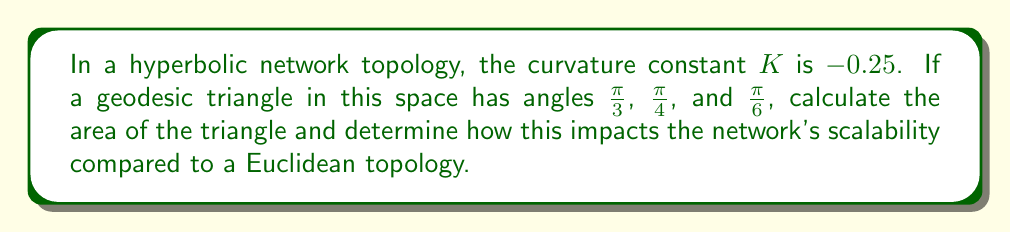Can you solve this math problem? 1) In hyperbolic geometry, the area $A$ of a triangle is given by the formula:

   $$A = \frac{(\alpha + \beta + \gamma - \pi)}{|K|}$$

   where $\alpha$, $\beta$, and $\gamma$ are the angles of the triangle, and $K$ is the curvature constant.

2) Given angles: $\alpha = \frac{\pi}{3}$, $\beta = \frac{\pi}{4}$, and $\gamma = \frac{\pi}{6}$

3) Sum of angles:
   $$\frac{\pi}{3} + \frac{\pi}{4} + \frac{\pi}{6} = \frac{4\pi}{12} + \frac{3\pi}{12} + \frac{2\pi}{12} = \frac{9\pi}{12} = \frac{3\pi}{4}$$

4) Substitute into the area formula:
   $$A = \frac{(\frac{3\pi}{4} - \pi)}{|-0.25|} = \frac{-\frac{\pi}{4}}{0.25} = -\pi$$

5) The negative area is a characteristic of hyperbolic geometry. The absolute value, $\pi$, represents the actual area.

6) In a hyperbolic network topology, this larger-than-expected triangle area implies that more nodes can be placed within a given region compared to a Euclidean topology. This leads to improved scalability, as the network can accommodate more devices or connections within the same logical space.

7) The exponential growth of available space in hyperbolic geometry allows for more efficient routing and addressing schemes, potentially reducing network congestion and improving overall performance as the network scales.
Answer: Area = $\pi$; Improved scalability due to exponential space growth. 